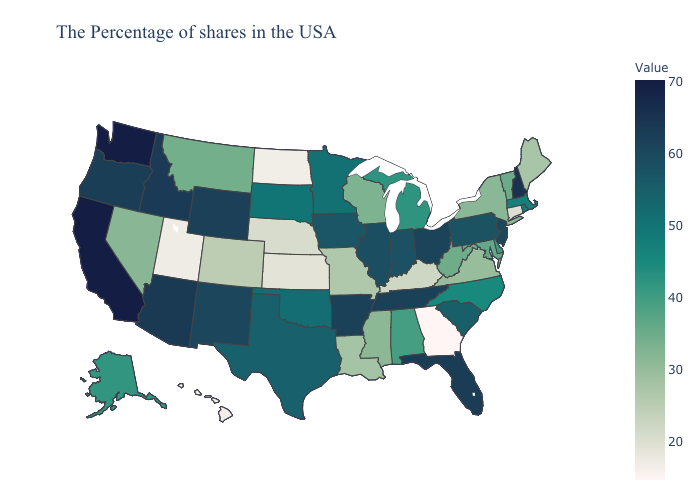Does the map have missing data?
Be succinct. No. Does Hawaii have the lowest value in the West?
Short answer required. Yes. Among the states that border Nebraska , does Colorado have the lowest value?
Answer briefly. No. Does Indiana have the lowest value in the USA?
Short answer required. No. Is the legend a continuous bar?
Keep it brief. Yes. 